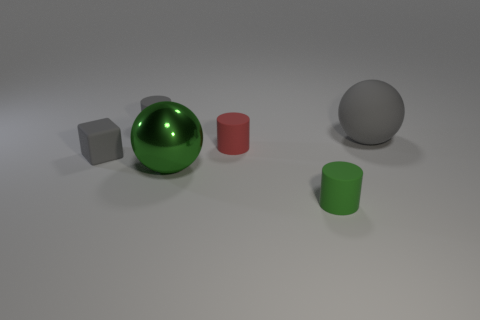Add 3 big gray rubber spheres. How many objects exist? 9 Subtract all blocks. How many objects are left? 5 Subtract all gray blocks. Subtract all big cyan rubber cubes. How many objects are left? 5 Add 2 small red rubber objects. How many small red rubber objects are left? 3 Add 3 tiny gray cylinders. How many tiny gray cylinders exist? 4 Subtract 1 gray balls. How many objects are left? 5 